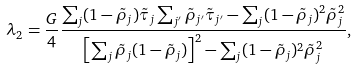<formula> <loc_0><loc_0><loc_500><loc_500>\lambda _ { 2 } = \frac { G } { 4 } \frac { \sum _ { j } ( 1 - \tilde { \rho } _ { j } ) \tilde { \tau } _ { j } \sum _ { j ^ { \prime } } \tilde { \rho } _ { j ^ { \prime } } \tilde { \tau } _ { j ^ { \prime } } - \sum _ { j } ( 1 - \tilde { \rho } _ { j } ) ^ { 2 } \tilde { \rho } _ { j } ^ { 2 } } { \left [ \sum _ { j } \tilde { \rho } _ { j } ( 1 - \tilde { \rho } _ { j } ) \right ] ^ { 2 } - \sum _ { j } ( 1 - \tilde { \rho } _ { j } ) ^ { 2 } \tilde { \rho } _ { j } ^ { 2 } } ,</formula> 